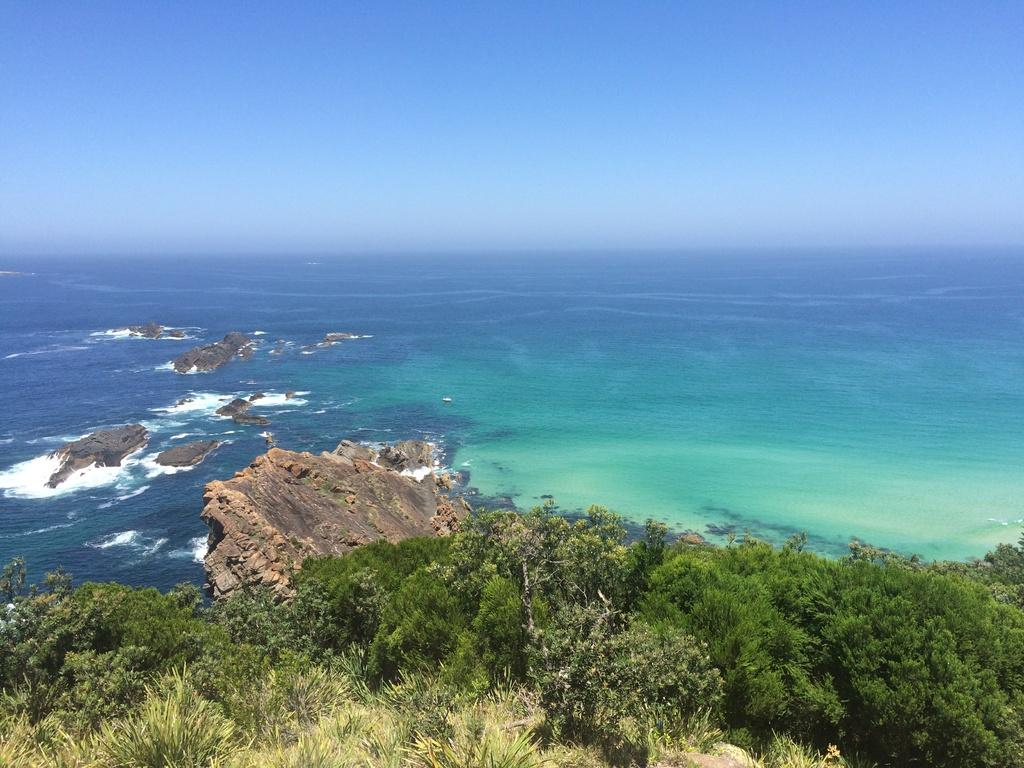What is the main feature of the image? There is a large water body in the image. What can be found within the water body? There are rocks in the water body. What type of vegetation is present in the image? There is a group of trees and plants in the image. What part of the natural environment is visible in the image? The sky is visible in the image. What language is being spoken by the needle in the image? There is no needle present in the image, and therefore no language being spoken. 